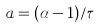<formula> <loc_0><loc_0><loc_500><loc_500>a = ( \alpha - 1 ) / \tau</formula> 